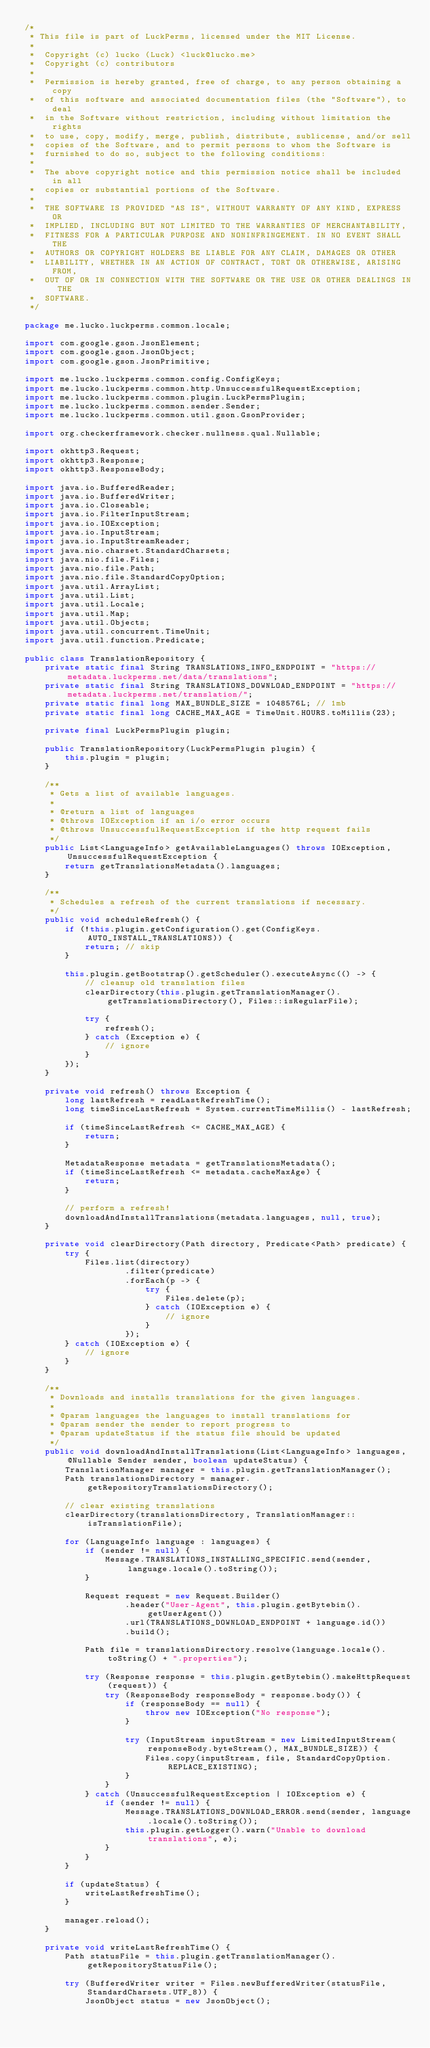Convert code to text. <code><loc_0><loc_0><loc_500><loc_500><_Java_>/*
 * This file is part of LuckPerms, licensed under the MIT License.
 *
 *  Copyright (c) lucko (Luck) <luck@lucko.me>
 *  Copyright (c) contributors
 *
 *  Permission is hereby granted, free of charge, to any person obtaining a copy
 *  of this software and associated documentation files (the "Software"), to deal
 *  in the Software without restriction, including without limitation the rights
 *  to use, copy, modify, merge, publish, distribute, sublicense, and/or sell
 *  copies of the Software, and to permit persons to whom the Software is
 *  furnished to do so, subject to the following conditions:
 *
 *  The above copyright notice and this permission notice shall be included in all
 *  copies or substantial portions of the Software.
 *
 *  THE SOFTWARE IS PROVIDED "AS IS", WITHOUT WARRANTY OF ANY KIND, EXPRESS OR
 *  IMPLIED, INCLUDING BUT NOT LIMITED TO THE WARRANTIES OF MERCHANTABILITY,
 *  FITNESS FOR A PARTICULAR PURPOSE AND NONINFRINGEMENT. IN NO EVENT SHALL THE
 *  AUTHORS OR COPYRIGHT HOLDERS BE LIABLE FOR ANY CLAIM, DAMAGES OR OTHER
 *  LIABILITY, WHETHER IN AN ACTION OF CONTRACT, TORT OR OTHERWISE, ARISING FROM,
 *  OUT OF OR IN CONNECTION WITH THE SOFTWARE OR THE USE OR OTHER DEALINGS IN THE
 *  SOFTWARE.
 */

package me.lucko.luckperms.common.locale;

import com.google.gson.JsonElement;
import com.google.gson.JsonObject;
import com.google.gson.JsonPrimitive;

import me.lucko.luckperms.common.config.ConfigKeys;
import me.lucko.luckperms.common.http.UnsuccessfulRequestException;
import me.lucko.luckperms.common.plugin.LuckPermsPlugin;
import me.lucko.luckperms.common.sender.Sender;
import me.lucko.luckperms.common.util.gson.GsonProvider;

import org.checkerframework.checker.nullness.qual.Nullable;

import okhttp3.Request;
import okhttp3.Response;
import okhttp3.ResponseBody;

import java.io.BufferedReader;
import java.io.BufferedWriter;
import java.io.Closeable;
import java.io.FilterInputStream;
import java.io.IOException;
import java.io.InputStream;
import java.io.InputStreamReader;
import java.nio.charset.StandardCharsets;
import java.nio.file.Files;
import java.nio.file.Path;
import java.nio.file.StandardCopyOption;
import java.util.ArrayList;
import java.util.List;
import java.util.Locale;
import java.util.Map;
import java.util.Objects;
import java.util.concurrent.TimeUnit;
import java.util.function.Predicate;

public class TranslationRepository {
    private static final String TRANSLATIONS_INFO_ENDPOINT = "https://metadata.luckperms.net/data/translations";
    private static final String TRANSLATIONS_DOWNLOAD_ENDPOINT = "https://metadata.luckperms.net/translation/";
    private static final long MAX_BUNDLE_SIZE = 1048576L; // 1mb
    private static final long CACHE_MAX_AGE = TimeUnit.HOURS.toMillis(23);

    private final LuckPermsPlugin plugin;

    public TranslationRepository(LuckPermsPlugin plugin) {
        this.plugin = plugin;
    }

    /**
     * Gets a list of available languages.
     *
     * @return a list of languages
     * @throws IOException if an i/o error occurs
     * @throws UnsuccessfulRequestException if the http request fails
     */
    public List<LanguageInfo> getAvailableLanguages() throws IOException, UnsuccessfulRequestException {
        return getTranslationsMetadata().languages;
    }

    /**
     * Schedules a refresh of the current translations if necessary.
     */
    public void scheduleRefresh() {
        if (!this.plugin.getConfiguration().get(ConfigKeys.AUTO_INSTALL_TRANSLATIONS)) {
            return; // skip
        }

        this.plugin.getBootstrap().getScheduler().executeAsync(() -> {
            // cleanup old translation files
            clearDirectory(this.plugin.getTranslationManager().getTranslationsDirectory(), Files::isRegularFile);

            try {
                refresh();
            } catch (Exception e) {
                // ignore
            }
        });
    }

    private void refresh() throws Exception {
        long lastRefresh = readLastRefreshTime();
        long timeSinceLastRefresh = System.currentTimeMillis() - lastRefresh;

        if (timeSinceLastRefresh <= CACHE_MAX_AGE) {
            return;
        }

        MetadataResponse metadata = getTranslationsMetadata();
        if (timeSinceLastRefresh <= metadata.cacheMaxAge) {
            return;
        }

        // perform a refresh!
        downloadAndInstallTranslations(metadata.languages, null, true);
    }

    private void clearDirectory(Path directory, Predicate<Path> predicate) {
        try {
            Files.list(directory)
                    .filter(predicate)
                    .forEach(p -> {
                        try {
                            Files.delete(p);
                        } catch (IOException e) {
                            // ignore
                        }
                    });
        } catch (IOException e) {
            // ignore
        }
    }

    /**
     * Downloads and installs translations for the given languages.
     *
     * @param languages the languages to install translations for
     * @param sender the sender to report progress to
     * @param updateStatus if the status file should be updated
     */
    public void downloadAndInstallTranslations(List<LanguageInfo> languages, @Nullable Sender sender, boolean updateStatus) {
        TranslationManager manager = this.plugin.getTranslationManager();
        Path translationsDirectory = manager.getRepositoryTranslationsDirectory();

        // clear existing translations
        clearDirectory(translationsDirectory, TranslationManager::isTranslationFile);

        for (LanguageInfo language : languages) {
            if (sender != null) {
                Message.TRANSLATIONS_INSTALLING_SPECIFIC.send(sender, language.locale().toString());
            }

            Request request = new Request.Builder()
                    .header("User-Agent", this.plugin.getBytebin().getUserAgent())
                    .url(TRANSLATIONS_DOWNLOAD_ENDPOINT + language.id())
                    .build();

            Path file = translationsDirectory.resolve(language.locale().toString() + ".properties");

            try (Response response = this.plugin.getBytebin().makeHttpRequest(request)) {
                try (ResponseBody responseBody = response.body()) {
                    if (responseBody == null) {
                        throw new IOException("No response");
                    }

                    try (InputStream inputStream = new LimitedInputStream(responseBody.byteStream(), MAX_BUNDLE_SIZE)) {
                        Files.copy(inputStream, file, StandardCopyOption.REPLACE_EXISTING);
                    }
                }
            } catch (UnsuccessfulRequestException | IOException e) {
                if (sender != null) {
                    Message.TRANSLATIONS_DOWNLOAD_ERROR.send(sender, language.locale().toString());
                    this.plugin.getLogger().warn("Unable to download translations", e);
                }
            }
        }

        if (updateStatus) {
            writeLastRefreshTime();
        }

        manager.reload();
    }

    private void writeLastRefreshTime() {
        Path statusFile = this.plugin.getTranslationManager().getRepositoryStatusFile();

        try (BufferedWriter writer = Files.newBufferedWriter(statusFile, StandardCharsets.UTF_8)) {
            JsonObject status = new JsonObject();</code> 